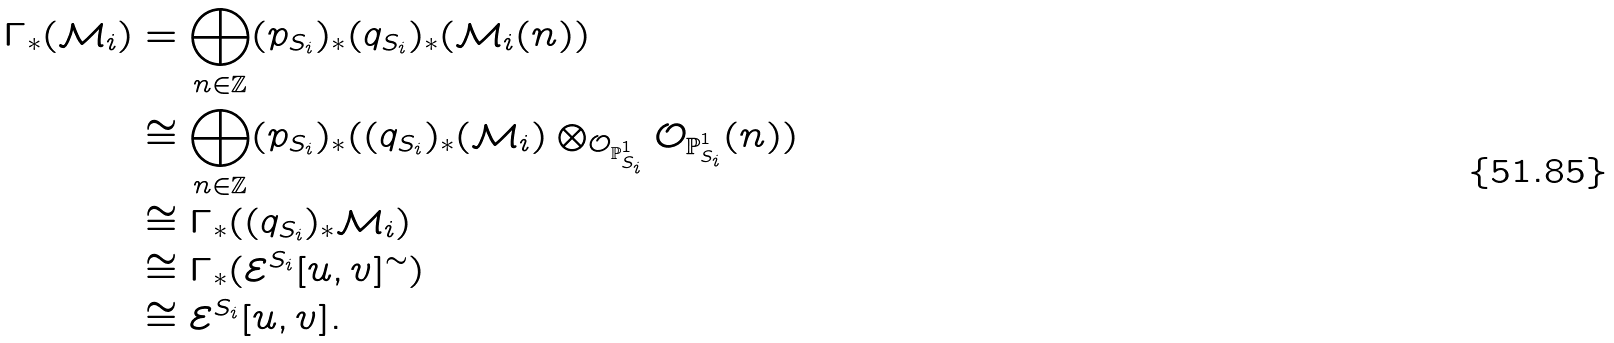<formula> <loc_0><loc_0><loc_500><loc_500>\Gamma _ { * } ( \mathcal { M } _ { i } ) & = \bigoplus _ { n \in \mathbb { Z } } ( p _ { S _ { i } } ) _ { * } ( q _ { S _ { i } } ) _ { * } ( \mathcal { M } _ { i } ( n ) ) \\ & \cong \bigoplus _ { n \in \mathbb { Z } } ( p _ { S _ { i } } ) _ { * } ( ( q _ { S _ { i } } ) _ { * } ( \mathcal { M } _ { i } ) \otimes _ { \mathcal { O } _ { \mathbb { P } ^ { 1 } _ { S _ { i } } } } \mathcal { O } _ { \mathbb { P } ^ { 1 } _ { S _ { i } } } ( n ) ) \\ & \cong \Gamma _ { * } ( ( q _ { S _ { i } } ) _ { * } \mathcal { M } _ { i } ) \\ & \cong \Gamma _ { * } ( \mathcal { E } ^ { S _ { i } } [ u , v ] ^ { \sim } ) \\ & \cong \mathcal { E } ^ { S _ { i } } [ u , v ] .</formula> 